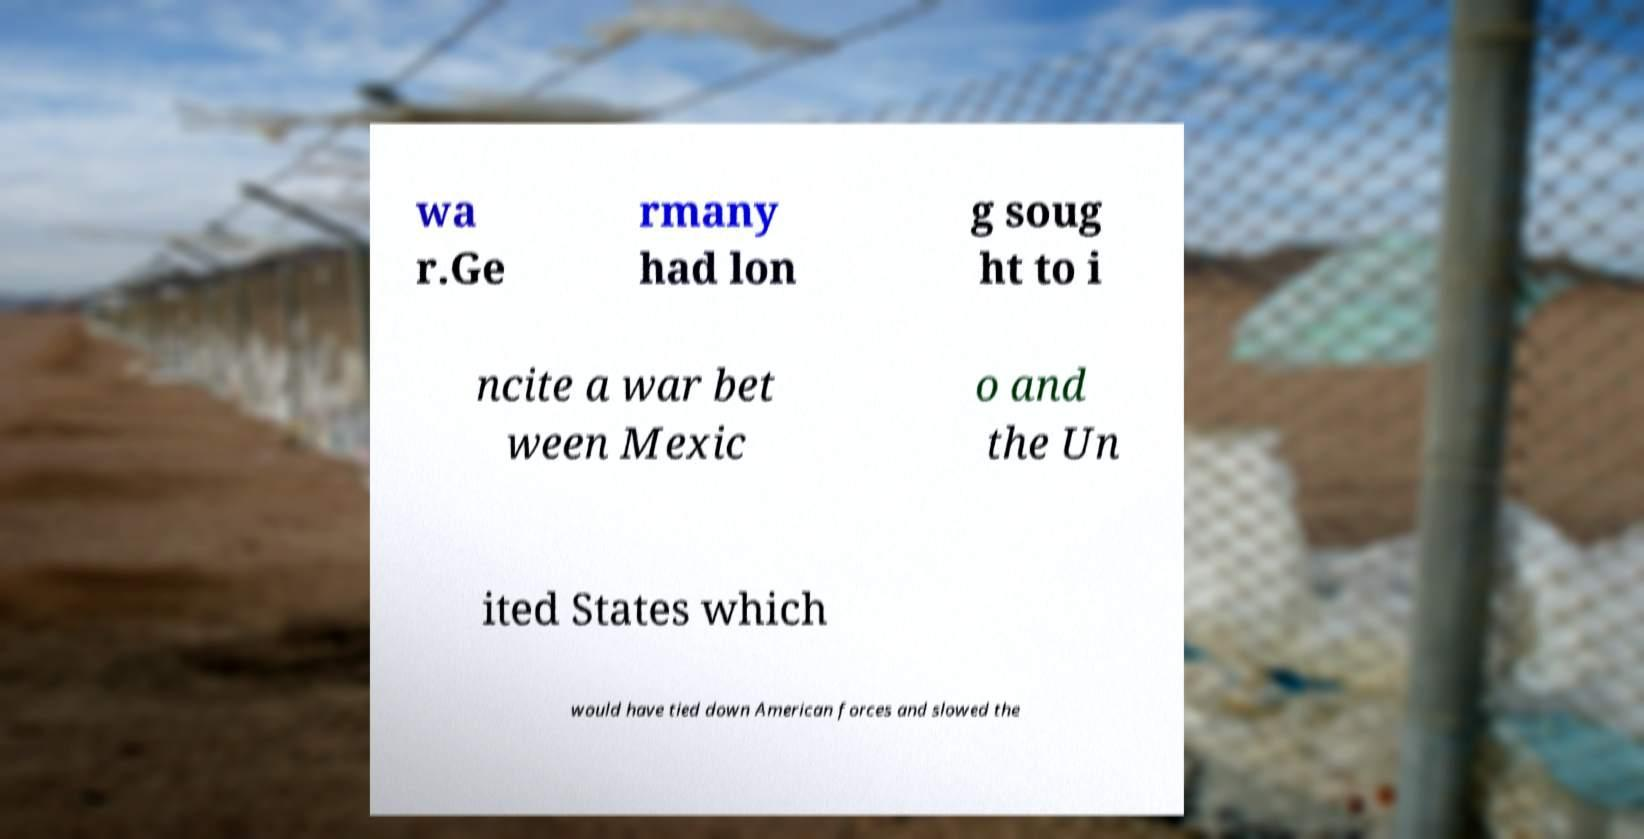Can you accurately transcribe the text from the provided image for me? wa r.Ge rmany had lon g soug ht to i ncite a war bet ween Mexic o and the Un ited States which would have tied down American forces and slowed the 